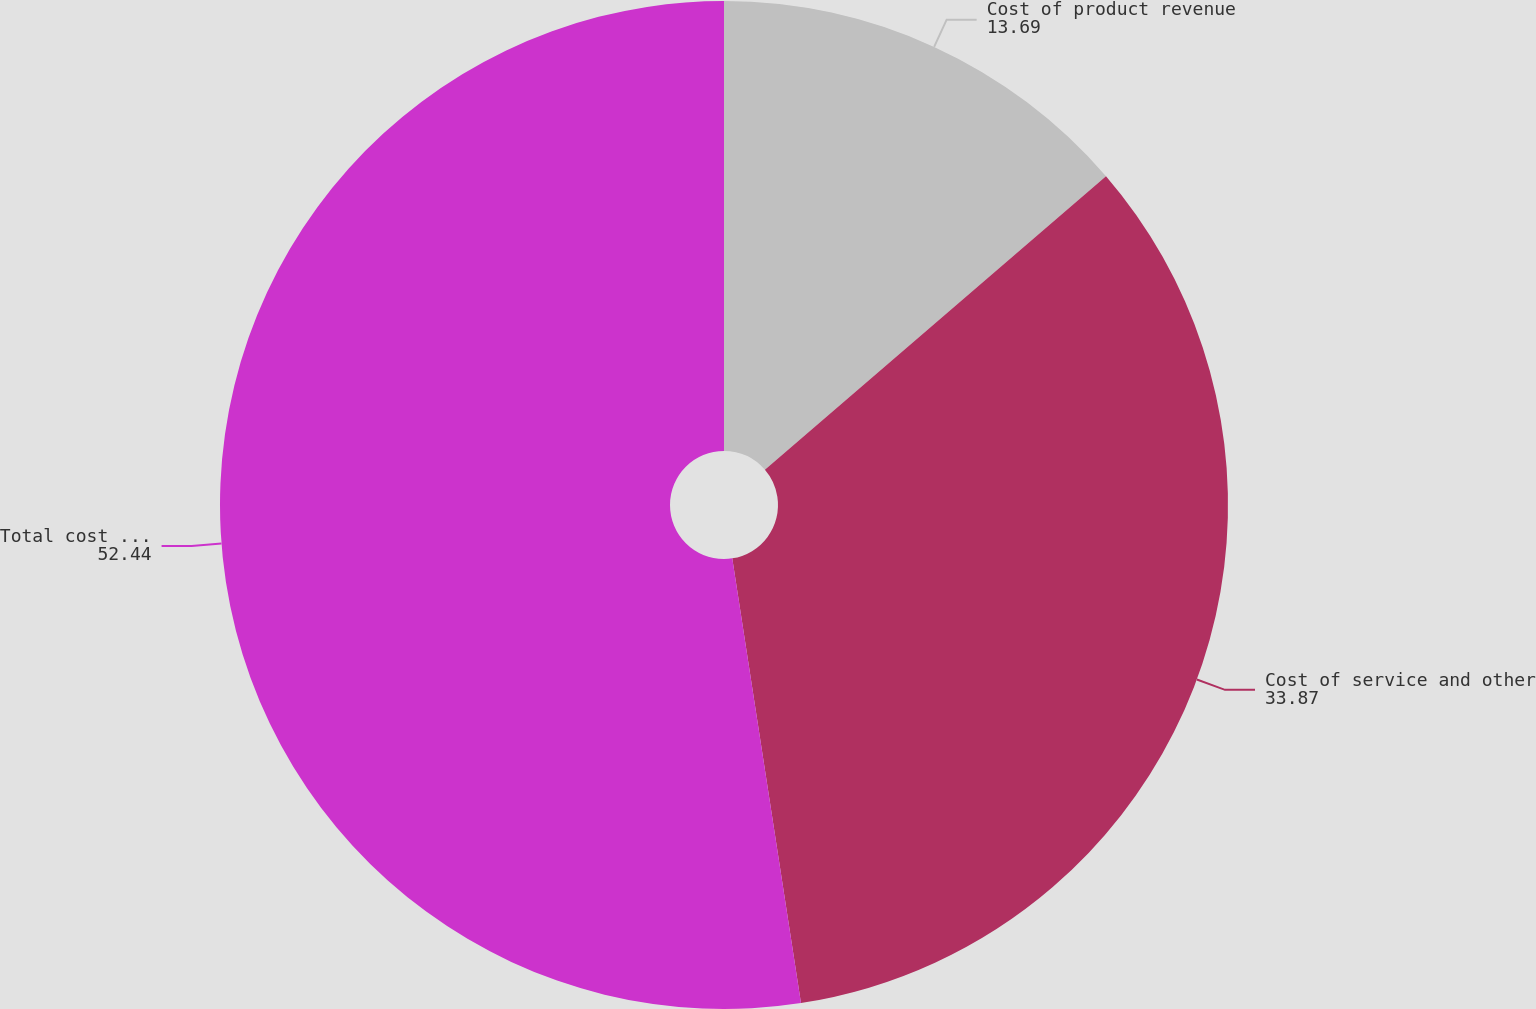<chart> <loc_0><loc_0><loc_500><loc_500><pie_chart><fcel>Cost of product revenue<fcel>Cost of service and other<fcel>Total cost of revenue<nl><fcel>13.69%<fcel>33.87%<fcel>52.44%<nl></chart> 